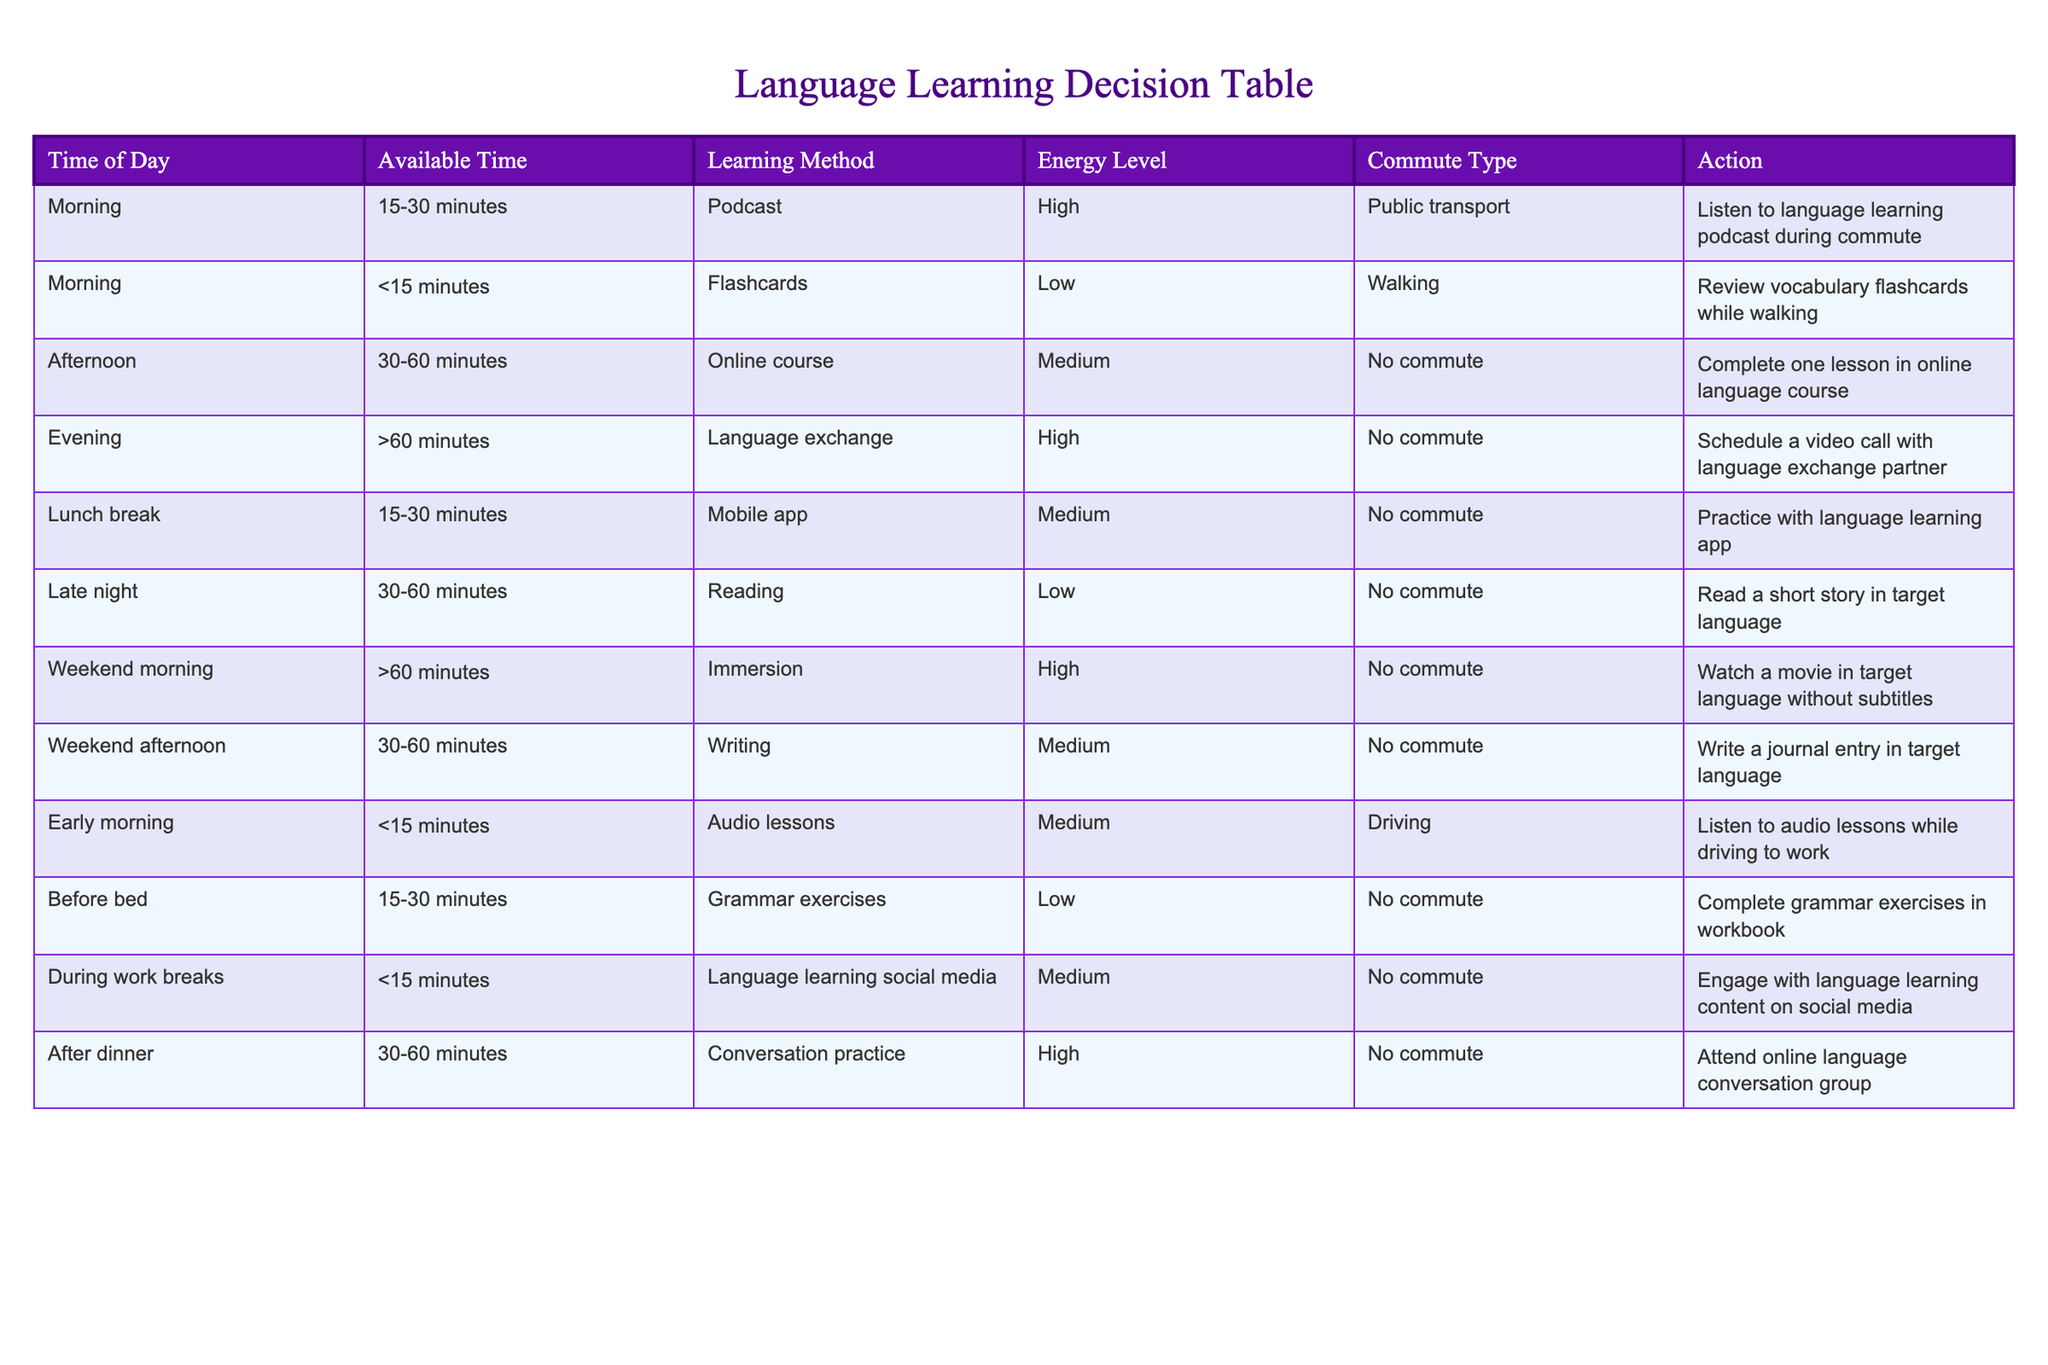What learning method is suggested for the early morning slot? Referring to the table, the early morning slot includes a suggested action of listening to audio lessons. Hence, the learning method for early morning is audio lessons.
Answer: Audio lessons How many time slots recommend engaging in language exchange? By examining the table, it shows that there is one time slot allocated for language exchange, which is during the evening when the suggested action is to schedule a video call with a language exchange partner.
Answer: One Which time of day offers the longest recommended learning session? Looking at the table, the weekend morning is noted for having a suggested learning method of immersion, which is set to last more than 60 minutes. Therefore, it has the longest recommended session.
Answer: Weekend morning Is it true that the lunch break can be used for practicing with a mobile app? The table confirms that during the lunch break, there is an action to practice with a language learning app. Thus, the statement is true.
Answer: Yes What methods can be used during a 30-60 minute session? The table indicates two methods for 30-60 minutes: the online course in the afternoon and conversation practice after dinner. Therefore, there are two methods for that timeframe.
Answer: Two methods 